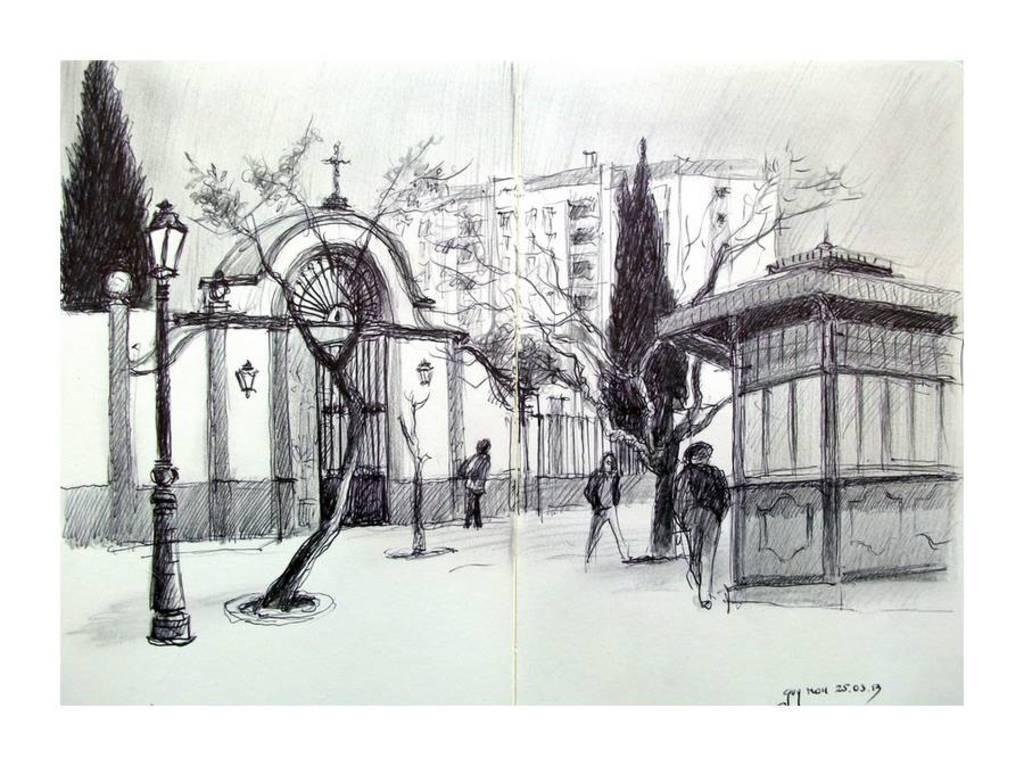Describe this image in one or two sentences. In this image I can see the sketch and I can see few persons standing, few light poles, trees, buildings and the image is in black and white. 